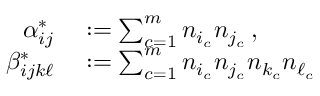Convert formula to latex. <formula><loc_0><loc_0><loc_500><loc_500>\begin{array} { r l } { \alpha _ { i j } ^ { * } } & \colon = \sum _ { c = 1 } ^ { m } n _ { i _ { c } } n _ { j _ { c } } \, , } \\ { \beta _ { i j k \ell } ^ { * } } & \colon = \sum _ { c = 1 } ^ { m } n _ { i _ { c } } n _ { j _ { c } } n _ { k _ { c } } n _ { \ell _ { c } } } \end{array}</formula> 